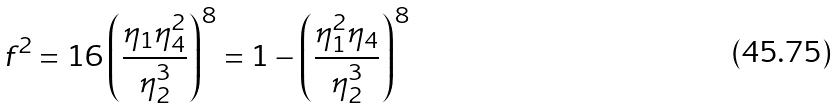Convert formula to latex. <formula><loc_0><loc_0><loc_500><loc_500>f ^ { 2 } = 1 6 \left ( \frac { \eta _ { 1 } \eta _ { 4 } ^ { 2 } } { \eta _ { 2 } ^ { 3 } } \right ) ^ { 8 } = 1 - \left ( \frac { \eta _ { 1 } ^ { 2 } \eta _ { 4 } } { \eta _ { 2 } ^ { 3 } } \right ) ^ { 8 }</formula> 